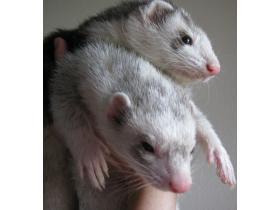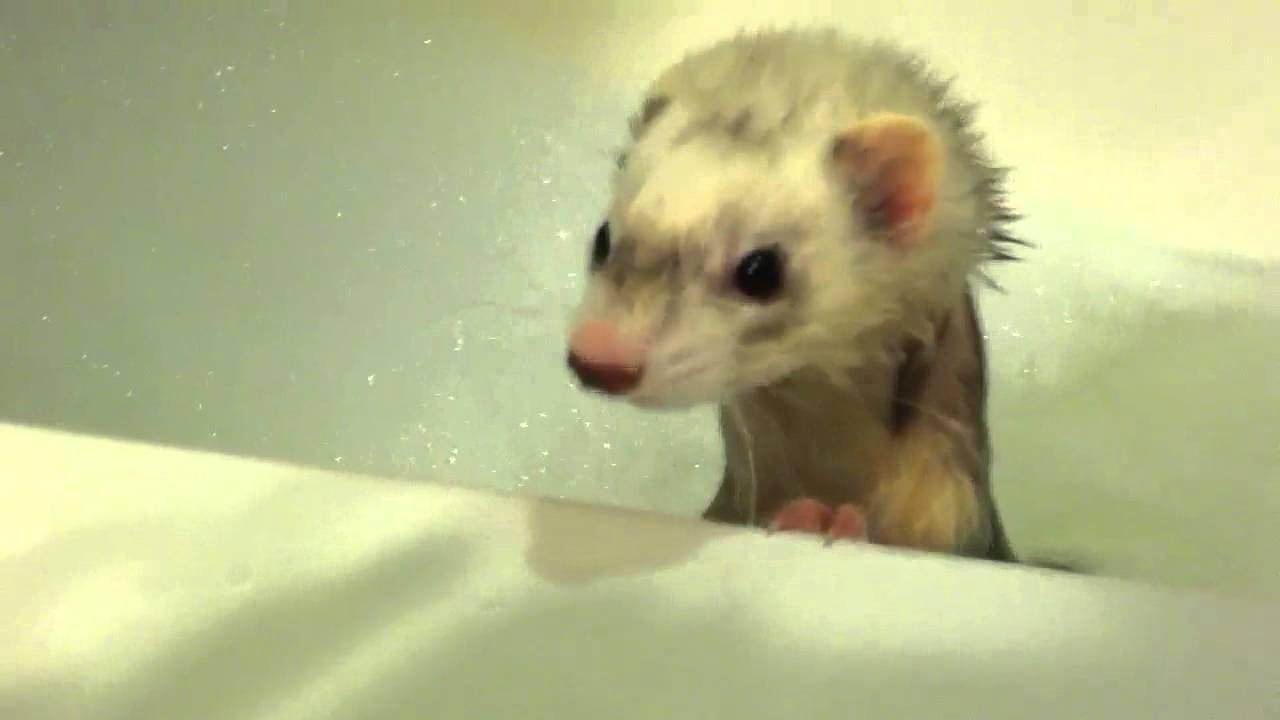The first image is the image on the left, the second image is the image on the right. Assess this claim about the two images: "The right image contains exactly two ferrets.". Correct or not? Answer yes or no. No. 